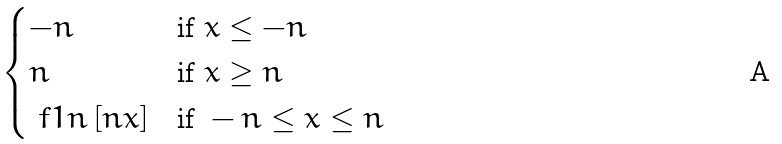Convert formula to latex. <formula><loc_0><loc_0><loc_500><loc_500>\begin{cases} - n & \text {if } x \leq - n \\ n & \text {if } x \geq n \\ \ f { 1 } { n } \, [ n x ] & \text {if } - n \leq x \leq n \end{cases}</formula> 